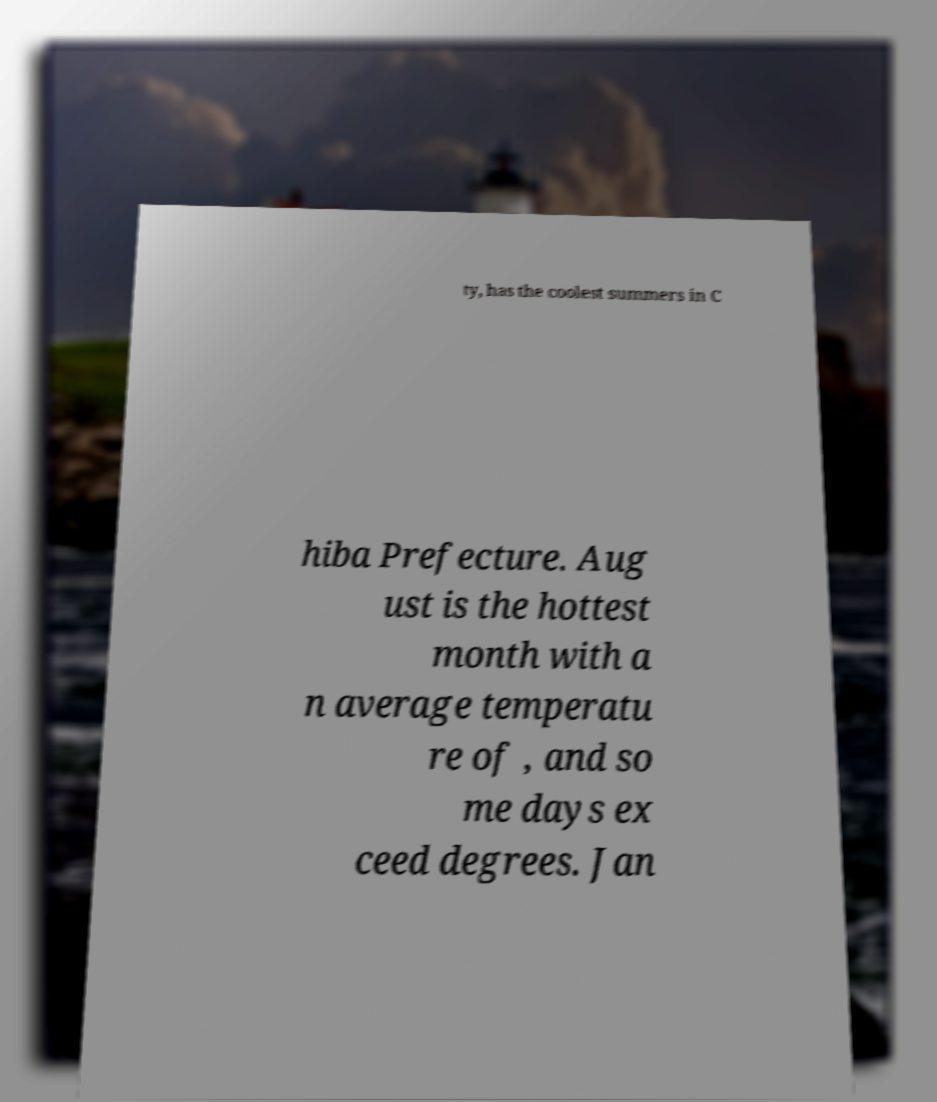What messages or text are displayed in this image? I need them in a readable, typed format. ty, has the coolest summers in C hiba Prefecture. Aug ust is the hottest month with a n average temperatu re of , and so me days ex ceed degrees. Jan 